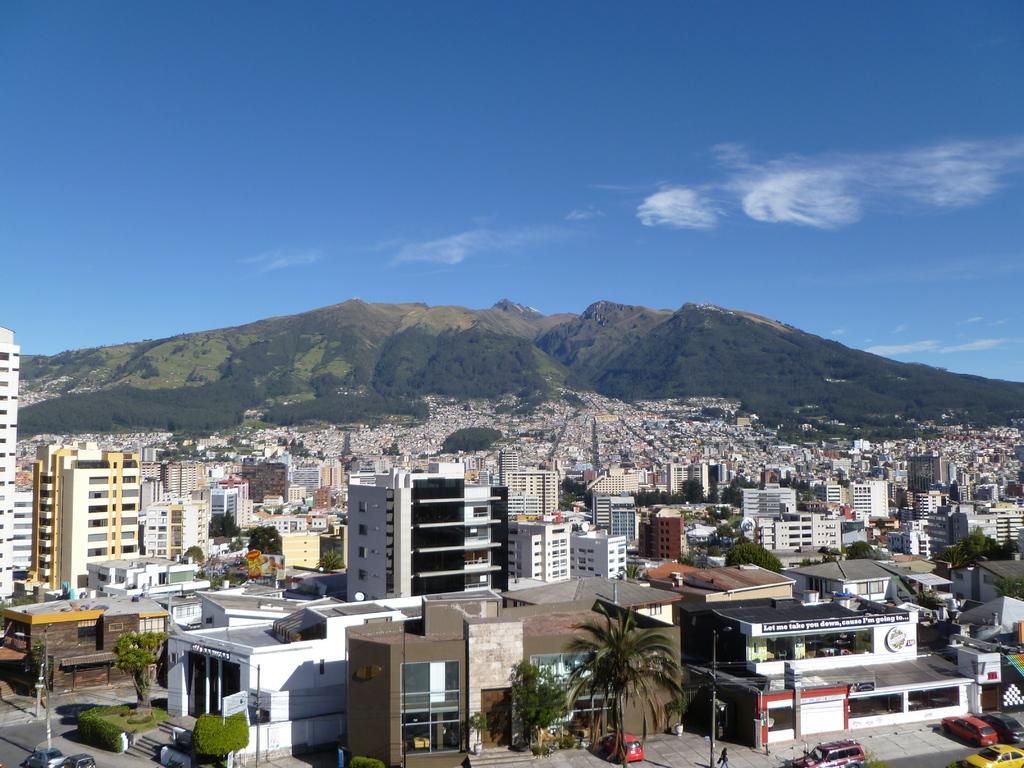Describe this image in one or two sentences. In this image we can see buildings, plants, trees, poles, road, boards, and vehicles. In the background we can see mountain and sky with clouds. 